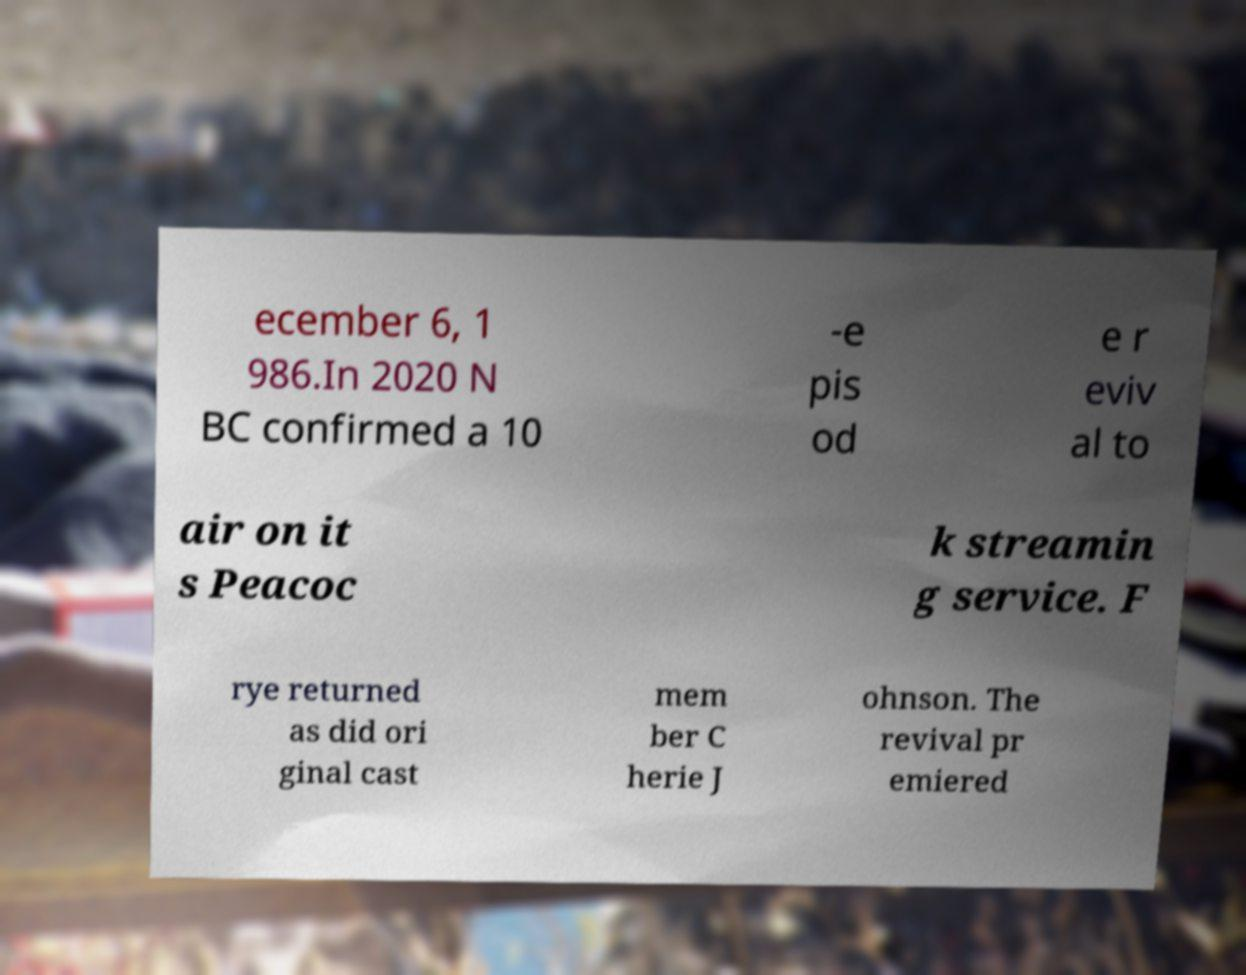Could you extract and type out the text from this image? ecember 6, 1 986.In 2020 N BC confirmed a 10 -e pis od e r eviv al to air on it s Peacoc k streamin g service. F rye returned as did ori ginal cast mem ber C herie J ohnson. The revival pr emiered 